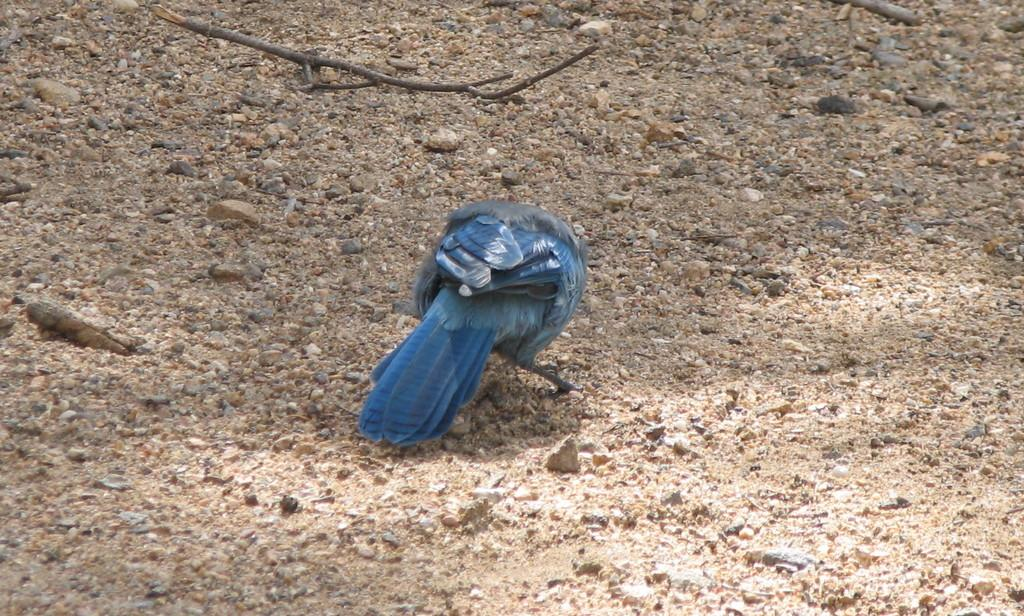What type of animal is on the ground in the image? There is a bird on the ground in the image. What else can be seen on the ground in the image? There are stones and sand on the ground in the image. What type of neck accessory is the bird wearing in the image? There is no neck accessory visible on the bird in the image. What type of chair is present in the image? There is no chair present in the image. 